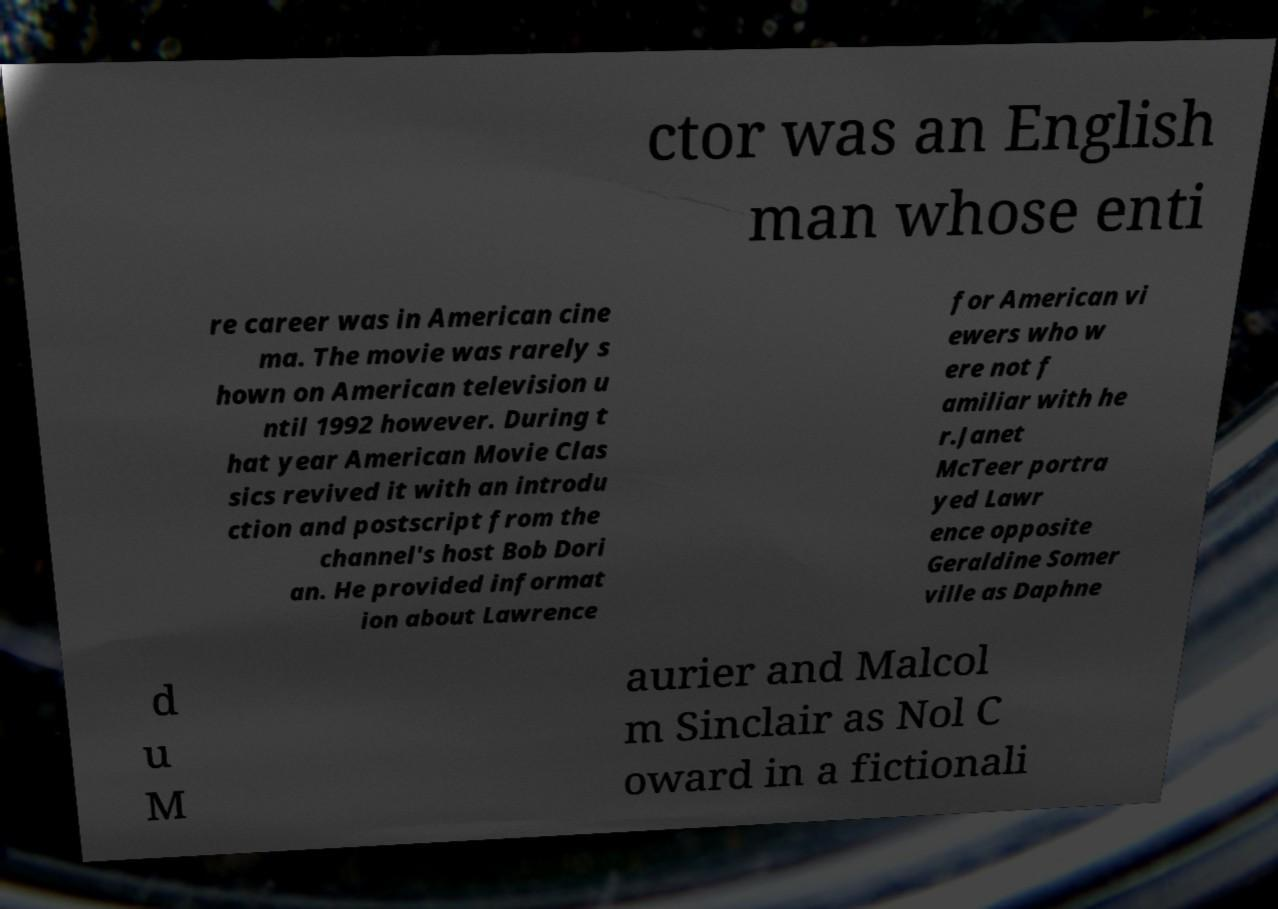I need the written content from this picture converted into text. Can you do that? ctor was an English man whose enti re career was in American cine ma. The movie was rarely s hown on American television u ntil 1992 however. During t hat year American Movie Clas sics revived it with an introdu ction and postscript from the channel's host Bob Dori an. He provided informat ion about Lawrence for American vi ewers who w ere not f amiliar with he r.Janet McTeer portra yed Lawr ence opposite Geraldine Somer ville as Daphne d u M aurier and Malcol m Sinclair as Nol C oward in a fictionali 